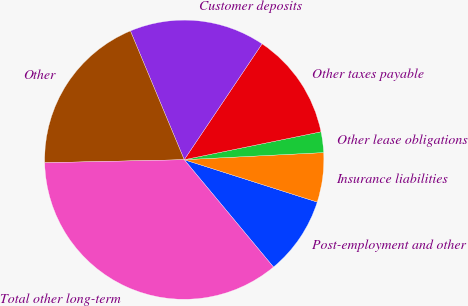Convert chart. <chart><loc_0><loc_0><loc_500><loc_500><pie_chart><fcel>Post-employment and other<fcel>Insurance liabilities<fcel>Other lease obligations<fcel>Other taxes payable<fcel>Customer deposits<fcel>Other<fcel>Total other long-term<nl><fcel>9.05%<fcel>5.72%<fcel>2.39%<fcel>12.38%<fcel>15.71%<fcel>19.04%<fcel>35.69%<nl></chart> 